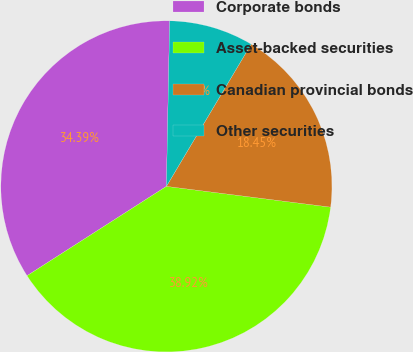Convert chart. <chart><loc_0><loc_0><loc_500><loc_500><pie_chart><fcel>Corporate bonds<fcel>Asset-backed securities<fcel>Canadian provincial bonds<fcel>Other securities<nl><fcel>34.39%<fcel>38.92%<fcel>18.45%<fcel>8.24%<nl></chart> 